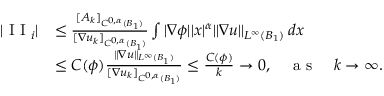<formula> <loc_0><loc_0><loc_500><loc_500>\begin{array} { r l } { | I I _ { i } | } & { \leq \frac { [ A _ { k } ] _ { C ^ { 0 , \alpha } ( B _ { 1 } ) } } { [ \nabla u _ { k } ] _ { C ^ { 0 , \alpha } ( B _ { 1 } ) } } \int | \nabla \phi | | x | ^ { \alpha } \| \nabla u \| _ { L ^ { \infty } ( B _ { 1 } ) } \, d x } \\ & { \leq C ( \phi ) \frac { \| \nabla u \| _ { L ^ { \infty } ( B _ { 1 } ) } } { [ \nabla u _ { k } ] _ { C ^ { 0 , \alpha } ( B _ { 1 } ) } } \leq \frac { C ( \phi ) } { k } \to 0 , \quad a s \quad k \to \infty . } \end{array}</formula> 